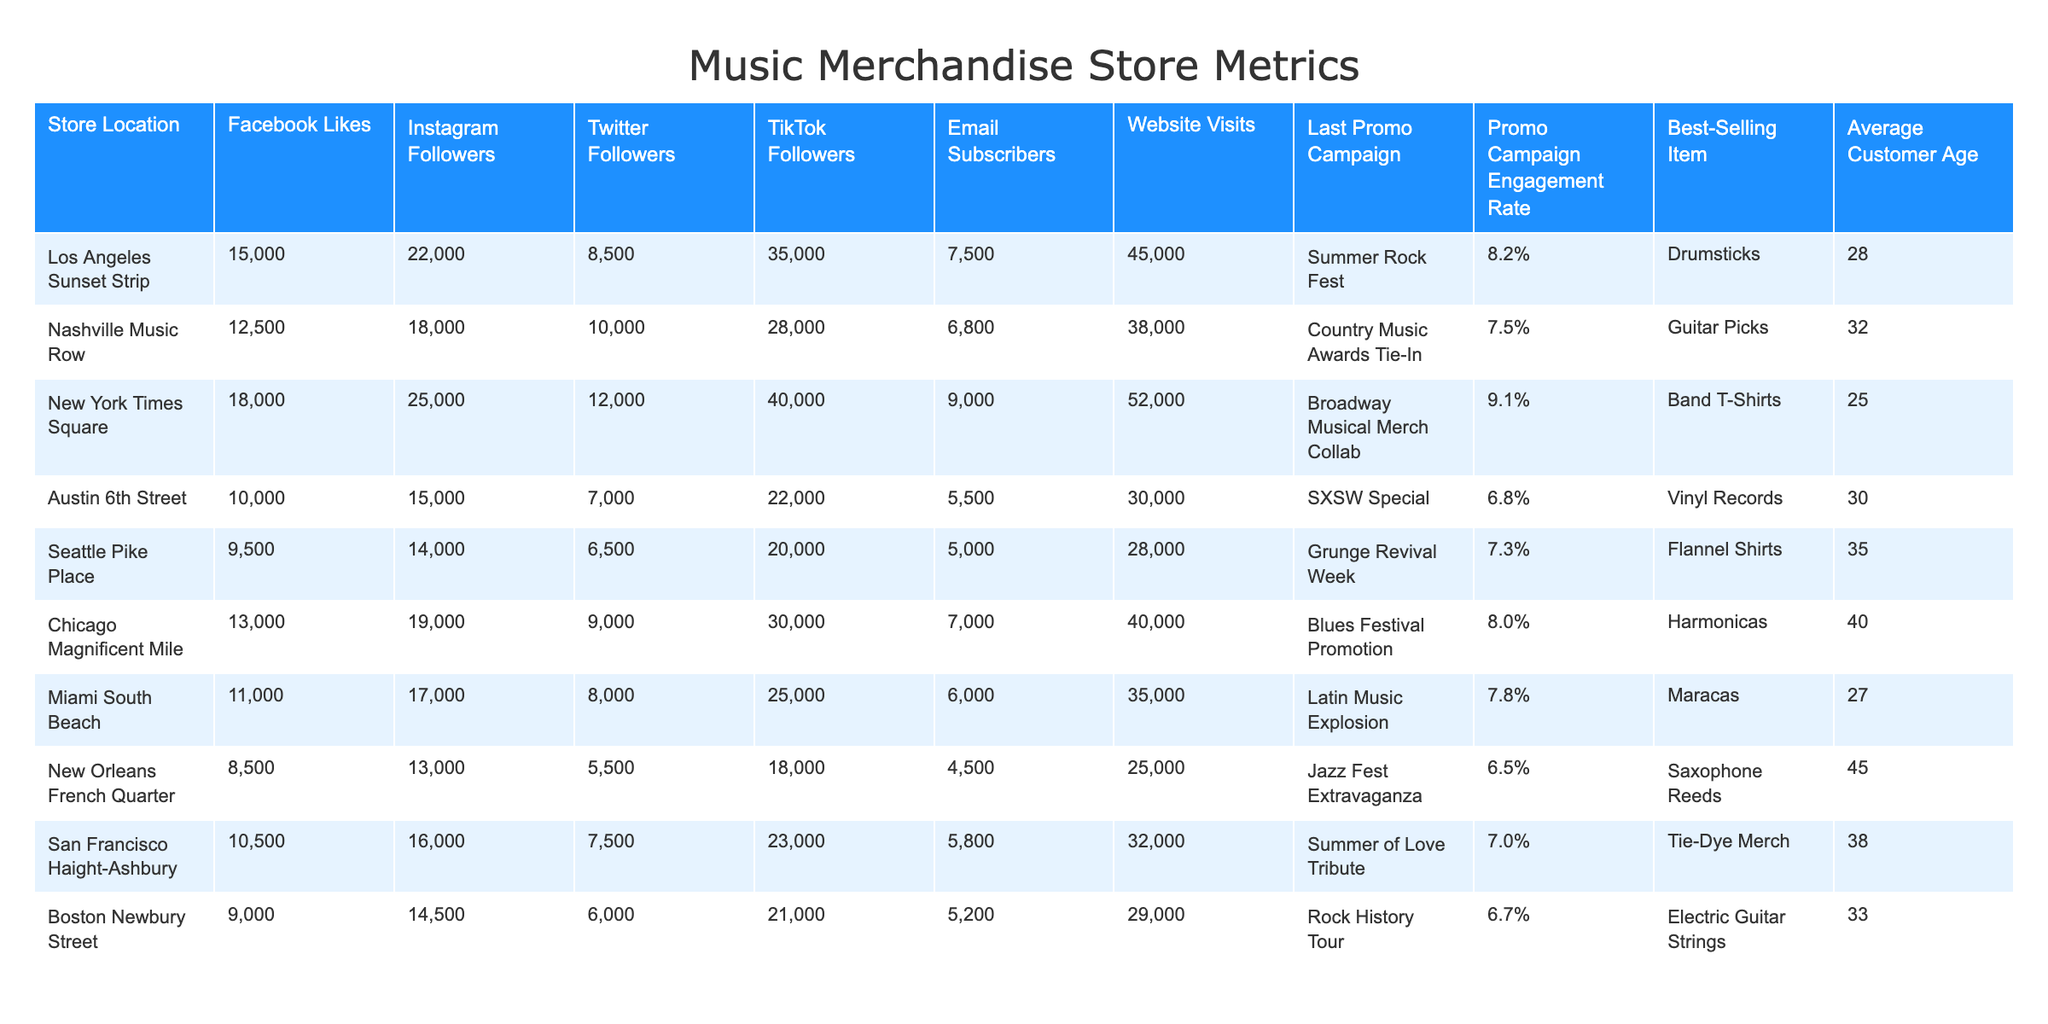What is the highest number of Instagram followers among the store locations? Referring to the table, New York Times Square has the highest number of Instagram followers with a total of 25,000.
Answer: 25,000 Which store location had the lowest Promo Campaign Engagement Rate? By examining the engagement rates, New Orleans French Quarter has the lowest engagement rate at 6.5%.
Answer: 6.5% What is the average customer age for the Los Angeles Sunset Strip store? The table shows that the average customer age for Los Angeles Sunset Strip is 28.
Answer: 28 How many more TikTok followers does New York Times Square have compared to Miami South Beach? New York Times Square has 40,000 TikTok followers, while Miami South Beach has 25,000. Calculating the difference: 40,000 - 25,000 = 15,000.
Answer: 15,000 Is Austin 6th Street's average customer age higher than that of Nashville Music Row? Austin 6th Street has an average customer age of 30 while Nashville Music Row has 32. Since 30 is not higher than 32, the answer is no.
Answer: No What is the total number of email subscribers for all store locations combined? Adding the email subscribers from the table gives: 7500 + 6800 + 9000 + 5500 + 5000 + 6000 + 4500 + 5200 = 46,500.
Answer: 46,500 Which store sold the best-selling item with the highest average customer age? Based on the data, the best-selling item with the highest average customer age is associated with Chicago Magnificent Mile, with an item of Harmonicas and an average age of 40.
Answer: Harmonicas How many website visits did the store with the highest Facebook Likes receive? The store with the highest Facebook likes is New York Times Square with 18,000 likes. It had 52,000 website visits.
Answer: 52,000 Which store had the last promotional campaign labeled as a "Jazz Fest Extravaganza"? The New Orleans French Quarter had the last promotional campaign named "Jazz Fest Extravaganza."
Answer: New Orleans French Quarter What is the difference between the total number of Facebook Likes and Instagram Followers for the Seattle Pike Place store? Seattle Pike Place has 9,500 Facebook Likes and 14,000 Instagram Followers. The difference is 14,000 - 9,500 = 4,500.
Answer: 4,500 